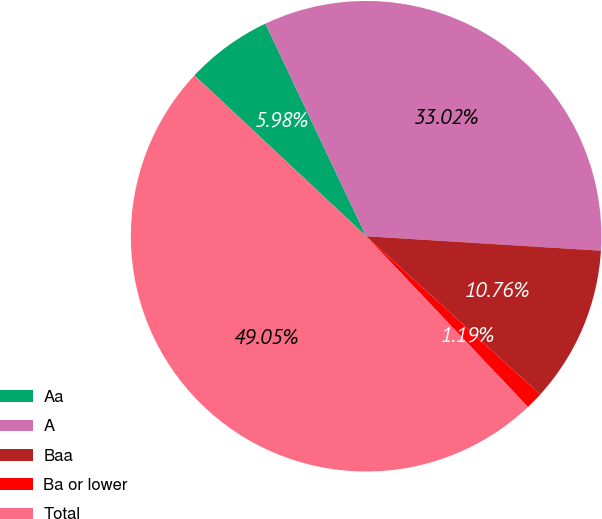Convert chart to OTSL. <chart><loc_0><loc_0><loc_500><loc_500><pie_chart><fcel>Aa<fcel>A<fcel>Baa<fcel>Ba or lower<fcel>Total<nl><fcel>5.98%<fcel>33.02%<fcel>10.76%<fcel>1.19%<fcel>49.05%<nl></chart> 